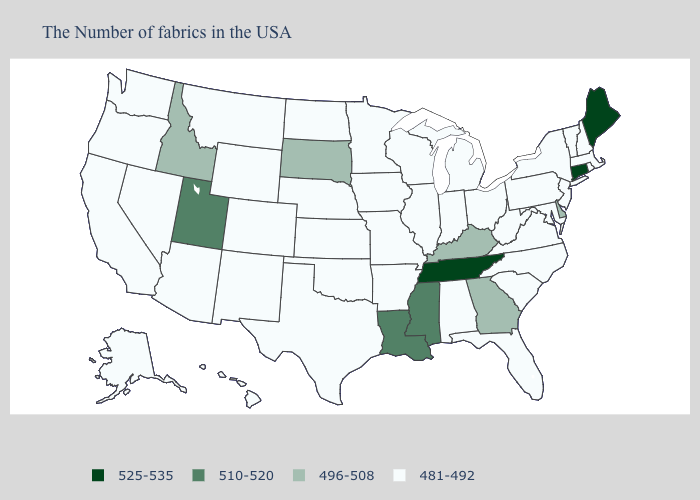Which states have the lowest value in the USA?
Concise answer only. Massachusetts, Rhode Island, New Hampshire, Vermont, New York, New Jersey, Maryland, Pennsylvania, Virginia, North Carolina, South Carolina, West Virginia, Ohio, Florida, Michigan, Indiana, Alabama, Wisconsin, Illinois, Missouri, Arkansas, Minnesota, Iowa, Kansas, Nebraska, Oklahoma, Texas, North Dakota, Wyoming, Colorado, New Mexico, Montana, Arizona, Nevada, California, Washington, Oregon, Alaska, Hawaii. Name the states that have a value in the range 510-520?
Be succinct. Mississippi, Louisiana, Utah. Does Michigan have a lower value than Kentucky?
Concise answer only. Yes. Does the map have missing data?
Keep it brief. No. What is the value of Massachusetts?
Keep it brief. 481-492. What is the value of Delaware?
Quick response, please. 496-508. Which states have the lowest value in the USA?
Give a very brief answer. Massachusetts, Rhode Island, New Hampshire, Vermont, New York, New Jersey, Maryland, Pennsylvania, Virginia, North Carolina, South Carolina, West Virginia, Ohio, Florida, Michigan, Indiana, Alabama, Wisconsin, Illinois, Missouri, Arkansas, Minnesota, Iowa, Kansas, Nebraska, Oklahoma, Texas, North Dakota, Wyoming, Colorado, New Mexico, Montana, Arizona, Nevada, California, Washington, Oregon, Alaska, Hawaii. Among the states that border Connecticut , which have the highest value?
Answer briefly. Massachusetts, Rhode Island, New York. Which states have the highest value in the USA?
Quick response, please. Maine, Connecticut, Tennessee. What is the lowest value in the MidWest?
Answer briefly. 481-492. What is the lowest value in the USA?
Be succinct. 481-492. Does the map have missing data?
Keep it brief. No. What is the value of Illinois?
Concise answer only. 481-492. Name the states that have a value in the range 481-492?
Give a very brief answer. Massachusetts, Rhode Island, New Hampshire, Vermont, New York, New Jersey, Maryland, Pennsylvania, Virginia, North Carolina, South Carolina, West Virginia, Ohio, Florida, Michigan, Indiana, Alabama, Wisconsin, Illinois, Missouri, Arkansas, Minnesota, Iowa, Kansas, Nebraska, Oklahoma, Texas, North Dakota, Wyoming, Colorado, New Mexico, Montana, Arizona, Nevada, California, Washington, Oregon, Alaska, Hawaii. Does Pennsylvania have the highest value in the Northeast?
Short answer required. No. 